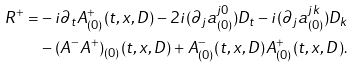<formula> <loc_0><loc_0><loc_500><loc_500>R ^ { + } = & - i \partial _ { t } A _ { ( 0 ) } ^ { + } ( t , x , D ) - 2 i ( \partial _ { j } a ^ { j 0 } _ { ( 0 ) } ) D _ { t } - i ( \partial _ { j } a ^ { j k } _ { ( 0 ) } ) D _ { k } \\ & - ( A ^ { - } A ^ { + } ) _ { ( 0 ) } ( t , x , D ) + A _ { ( 0 ) } ^ { - } ( t , x , D ) A _ { ( 0 ) } ^ { + } ( t , x , D ) .</formula> 